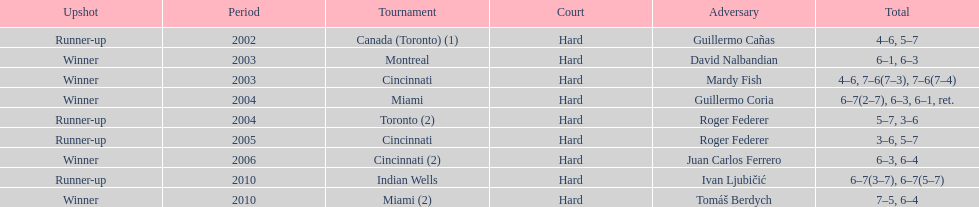How many total wins has he had? 5. 